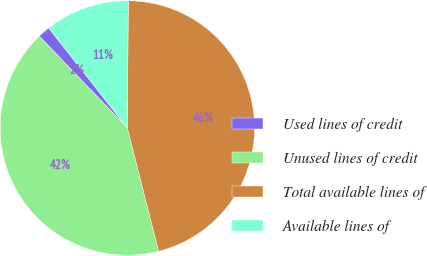Convert chart to OTSL. <chart><loc_0><loc_0><loc_500><loc_500><pie_chart><fcel>Used lines of credit<fcel>Unused lines of credit<fcel>Total available lines of<fcel>Available lines of<nl><fcel>1.57%<fcel>41.77%<fcel>45.94%<fcel>10.72%<nl></chart> 